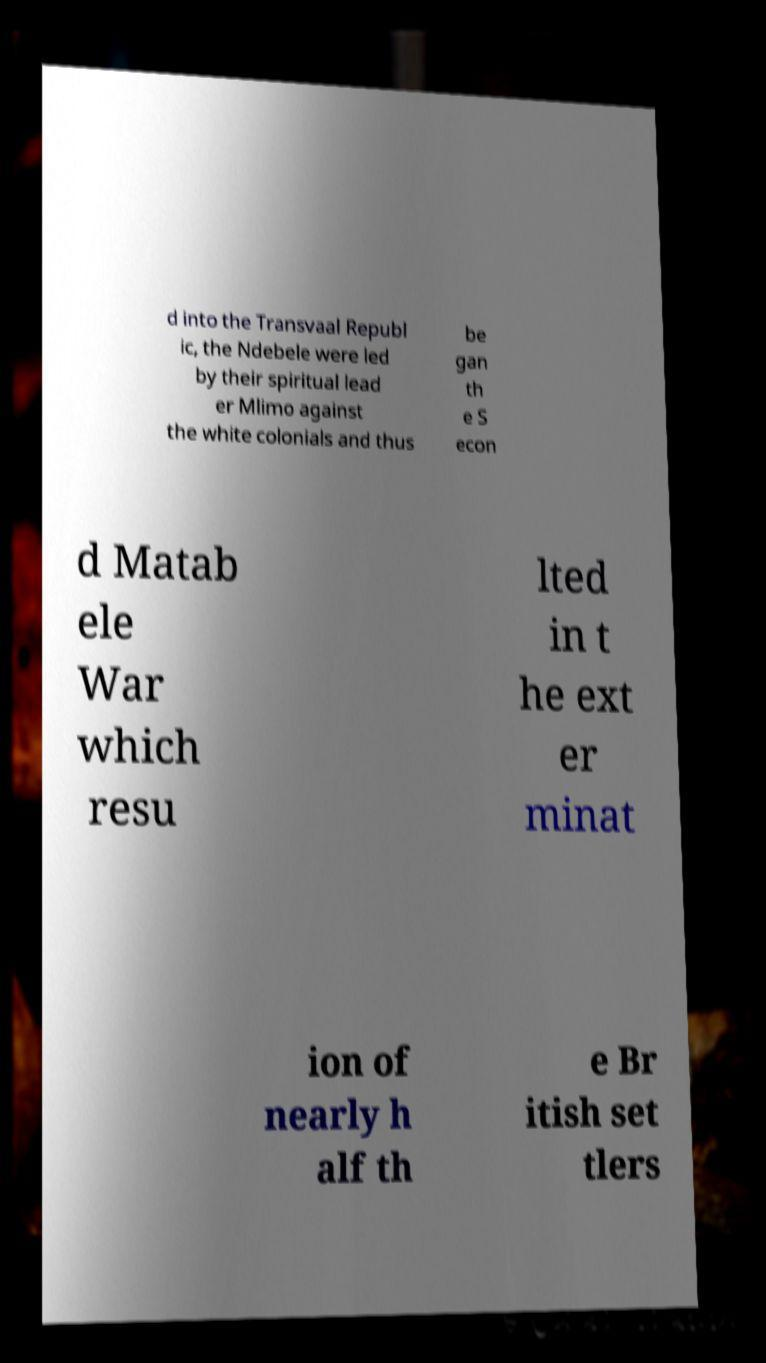Can you explain more about the historical context mentioned in this image? The image refers to the Second Matabele War, also known as the Matabeleland Rebellion, which took place in the late 19th century. This conflict involved the Ndebele (Matabele) people in Zimbabwe against British colonization efforts, led by their spiritual leader, Mlimo. The war was notable for its fierce resistance against European expansion in Southern Africa. 